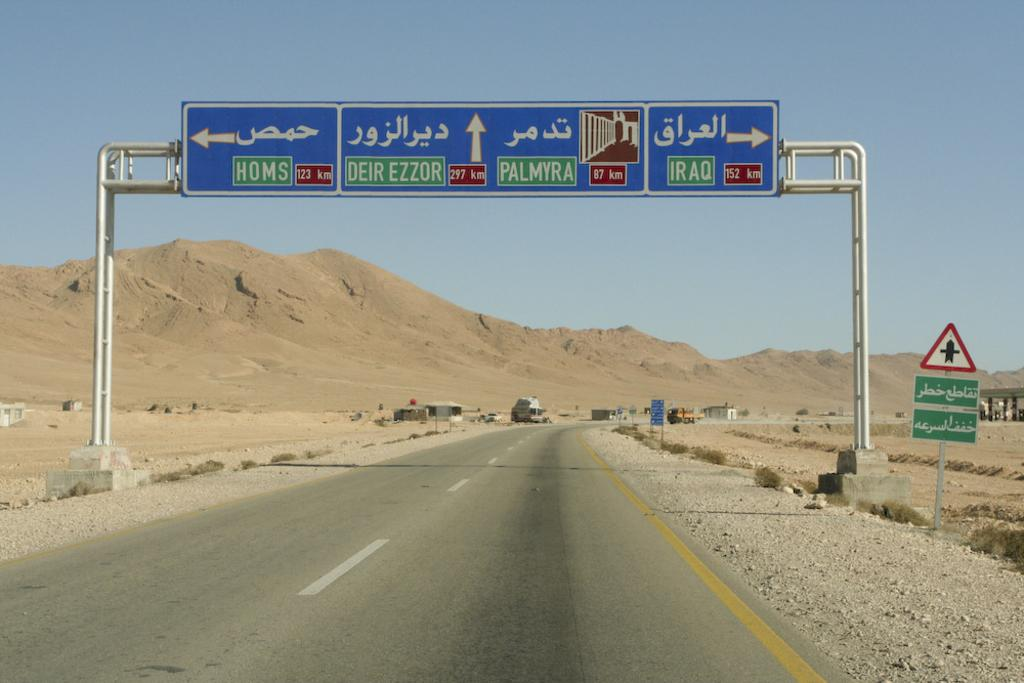<image>
Render a clear and concise summary of the photo. On a highway, there's an overhead board with four directional signs in blue with white trim that say HOMS, DEIR EZZOR, PALMYRA, and IRAQ, 